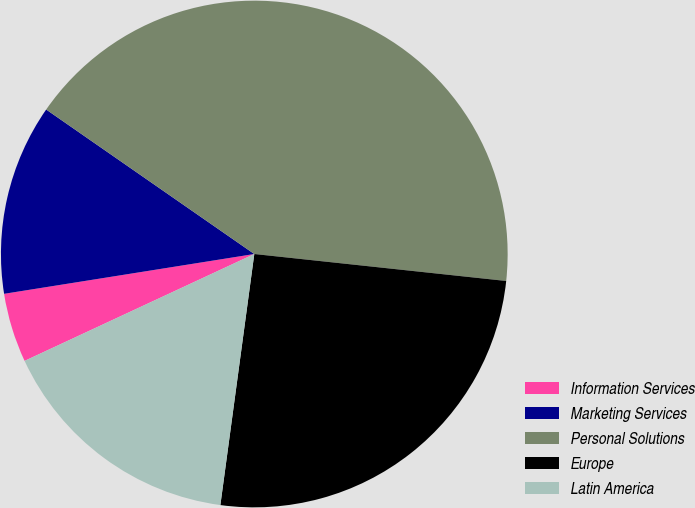Convert chart to OTSL. <chart><loc_0><loc_0><loc_500><loc_500><pie_chart><fcel>Information Services<fcel>Marketing Services<fcel>Personal Solutions<fcel>Europe<fcel>Latin America<nl><fcel>4.42%<fcel>12.17%<fcel>42.04%<fcel>25.44%<fcel>15.93%<nl></chart> 